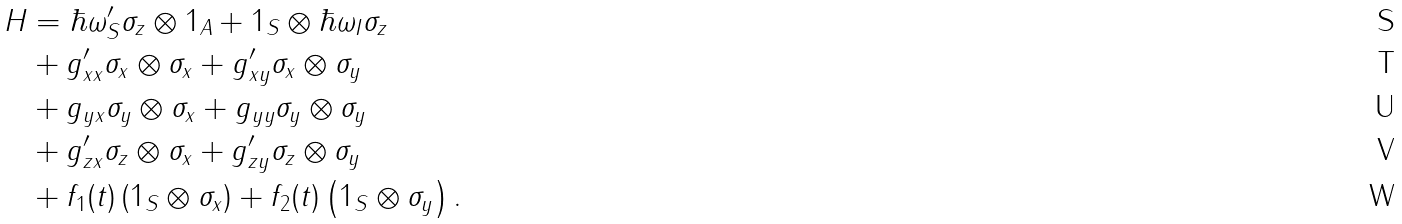Convert formula to latex. <formula><loc_0><loc_0><loc_500><loc_500>H & = \hbar { \omega } _ { S } ^ { \prime } \sigma _ { z } \otimes 1 _ { A } + 1 _ { S } \otimes \hbar { \omega } _ { I } \sigma _ { z } \\ & + g _ { x x } ^ { \prime } \sigma _ { x } \otimes \sigma _ { x } + g _ { x y } ^ { \prime } \sigma _ { x } \otimes \sigma _ { y } \\ & + g _ { y x } \sigma _ { y } \otimes \sigma _ { x } + g _ { y y } \sigma _ { y } \otimes \sigma _ { y } \\ & + g _ { z x } ^ { \prime } \sigma _ { z } \otimes \sigma _ { x } + g _ { z y } ^ { \prime } \sigma _ { z } \otimes \sigma _ { y } \\ & + f _ { 1 } ( t ) \left ( 1 _ { S } \otimes \sigma _ { x } \right ) + f _ { 2 } ( t ) \left ( 1 _ { S } \otimes \sigma _ { y } \right ) .</formula> 